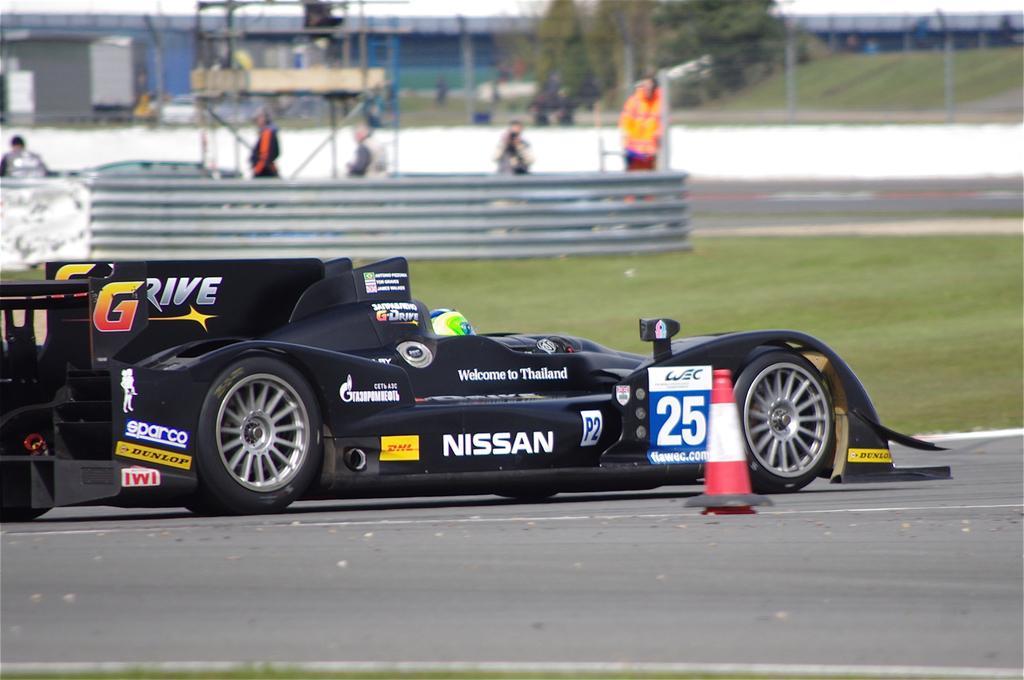Could you give a brief overview of what you see in this image? In this image, at the bottom there is a car, inside that there is a person. At the bottom there is a road, traffic cone. In the background there are people, grass, fence, trees, net, building. 